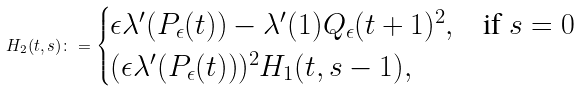<formula> <loc_0><loc_0><loc_500><loc_500>H _ { 2 } ( t , s ) \colon = \begin{cases} \epsilon \lambda ^ { \prime } ( P _ { \epsilon } ( t ) ) - \lambda ^ { \prime } ( 1 ) Q _ { \epsilon } ( t + 1 ) ^ { 2 } , & \text {if } s = 0 \\ ( \epsilon \lambda ^ { \prime } ( P _ { \epsilon } ( t ) ) ) ^ { 2 } H _ { 1 } ( t , s - 1 ) , \end{cases}</formula> 